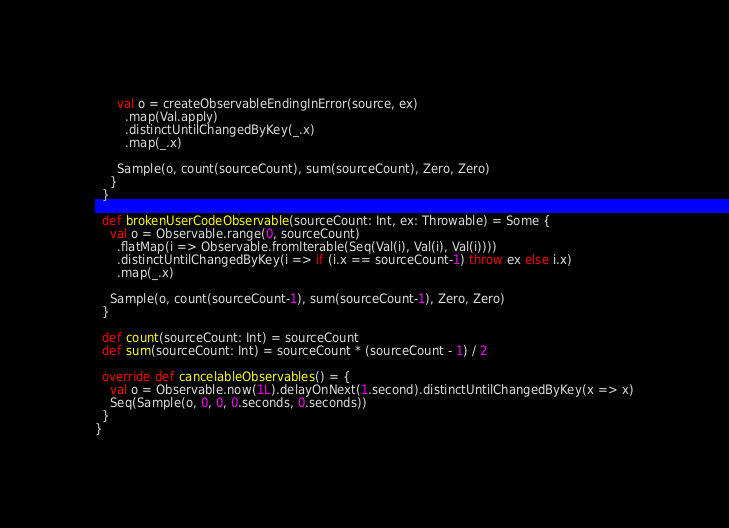Convert code to text. <code><loc_0><loc_0><loc_500><loc_500><_Scala_>
      val o = createObservableEndingInError(source, ex)
        .map(Val.apply)
        .distinctUntilChangedByKey(_.x)
        .map(_.x)

      Sample(o, count(sourceCount), sum(sourceCount), Zero, Zero)
    }
  }

  def brokenUserCodeObservable(sourceCount: Int, ex: Throwable) = Some {
    val o = Observable.range(0, sourceCount)
      .flatMap(i => Observable.fromIterable(Seq(Val(i), Val(i), Val(i))))
      .distinctUntilChangedByKey(i => if (i.x == sourceCount-1) throw ex else i.x)
      .map(_.x)

    Sample(o, count(sourceCount-1), sum(sourceCount-1), Zero, Zero)
  }

  def count(sourceCount: Int) = sourceCount
  def sum(sourceCount: Int) = sourceCount * (sourceCount - 1) / 2

  override def cancelableObservables() = {
    val o = Observable.now(1L).delayOnNext(1.second).distinctUntilChangedByKey(x => x)
    Seq(Sample(o, 0, 0, 0.seconds, 0.seconds))
  }
}
</code> 